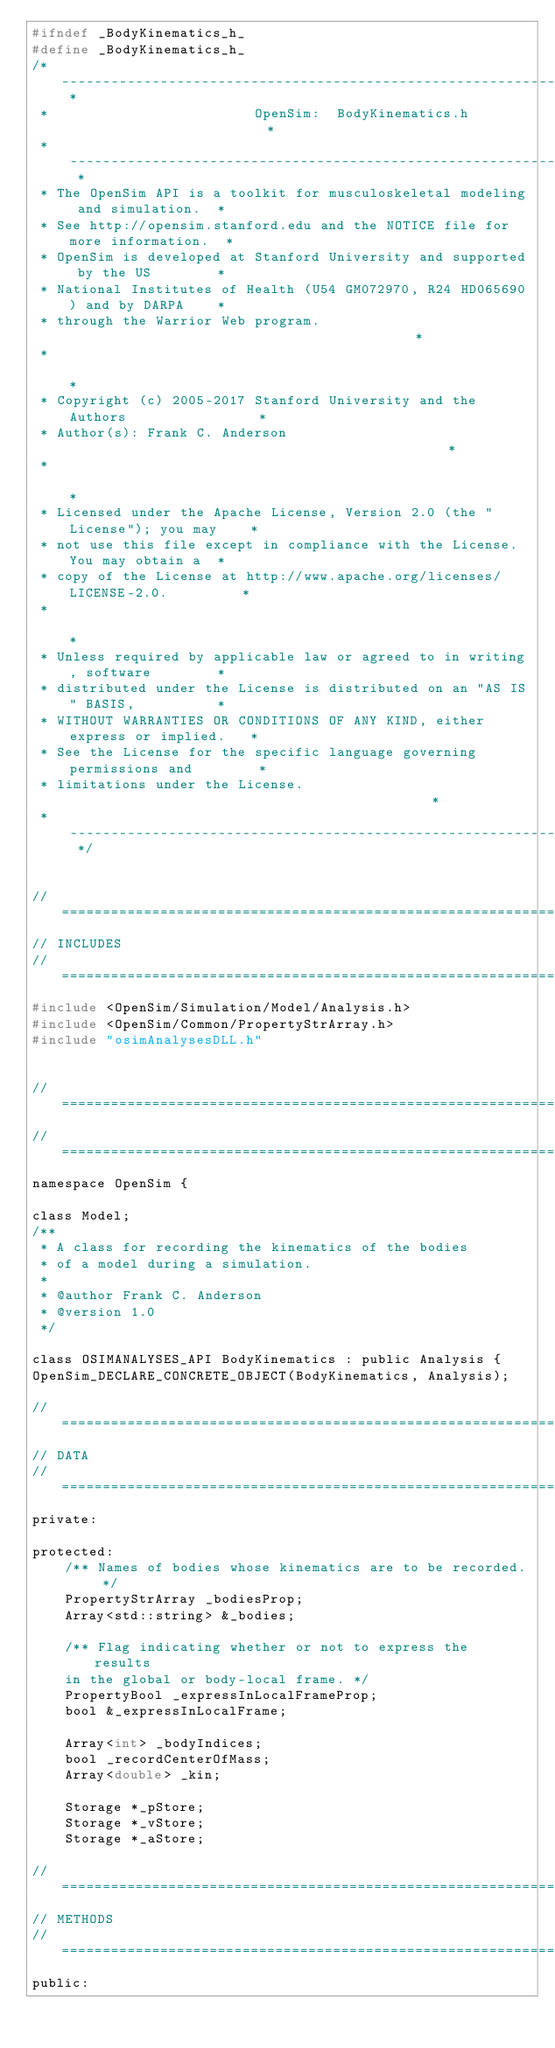<code> <loc_0><loc_0><loc_500><loc_500><_C_>#ifndef _BodyKinematics_h_
#define _BodyKinematics_h_
/* -------------------------------------------------------------------------- *
 *                         OpenSim:  BodyKinematics.h                         *
 * -------------------------------------------------------------------------- *
 * The OpenSim API is a toolkit for musculoskeletal modeling and simulation.  *
 * See http://opensim.stanford.edu and the NOTICE file for more information.  *
 * OpenSim is developed at Stanford University and supported by the US        *
 * National Institutes of Health (U54 GM072970, R24 HD065690) and by DARPA    *
 * through the Warrior Web program.                                           *
 *                                                                            *
 * Copyright (c) 2005-2017 Stanford University and the Authors                *
 * Author(s): Frank C. Anderson                                               *
 *                                                                            *
 * Licensed under the Apache License, Version 2.0 (the "License"); you may    *
 * not use this file except in compliance with the License. You may obtain a  *
 * copy of the License at http://www.apache.org/licenses/LICENSE-2.0.         *
 *                                                                            *
 * Unless required by applicable law or agreed to in writing, software        *
 * distributed under the License is distributed on an "AS IS" BASIS,          *
 * WITHOUT WARRANTIES OR CONDITIONS OF ANY KIND, either express or implied.   *
 * See the License for the specific language governing permissions and        *
 * limitations under the License.                                             *
 * -------------------------------------------------------------------------- */


//=============================================================================
// INCLUDES
//=============================================================================
#include <OpenSim/Simulation/Model/Analysis.h>
#include <OpenSim/Common/PropertyStrArray.h>
#include "osimAnalysesDLL.h"


//=============================================================================
//=============================================================================
namespace OpenSim { 

class Model;
/**
 * A class for recording the kinematics of the bodies
 * of a model during a simulation.
 *
 * @author Frank C. Anderson
 * @version 1.0
 */

class OSIMANALYSES_API BodyKinematics : public Analysis {
OpenSim_DECLARE_CONCRETE_OBJECT(BodyKinematics, Analysis);

//=============================================================================
// DATA
//=============================================================================
private:

protected:
    /** Names of bodies whose kinematics are to be recorded. */
    PropertyStrArray _bodiesProp;
    Array<std::string> &_bodies;

    /** Flag indicating whether or not to express the results
    in the global or body-local frame. */
    PropertyBool _expressInLocalFrameProp;
    bool &_expressInLocalFrame;

    Array<int> _bodyIndices;
    bool _recordCenterOfMass;
    Array<double> _kin;

    Storage *_pStore;
    Storage *_vStore;
    Storage *_aStore;

//=============================================================================
// METHODS
//=============================================================================
public:</code> 